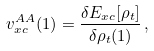Convert formula to latex. <formula><loc_0><loc_0><loc_500><loc_500>v _ { x c } ^ { A A } ( { 1 } ) = \frac { \delta E _ { x c } [ \rho _ { t } ] } { \delta \rho _ { t } ( 1 ) } \, ,</formula> 